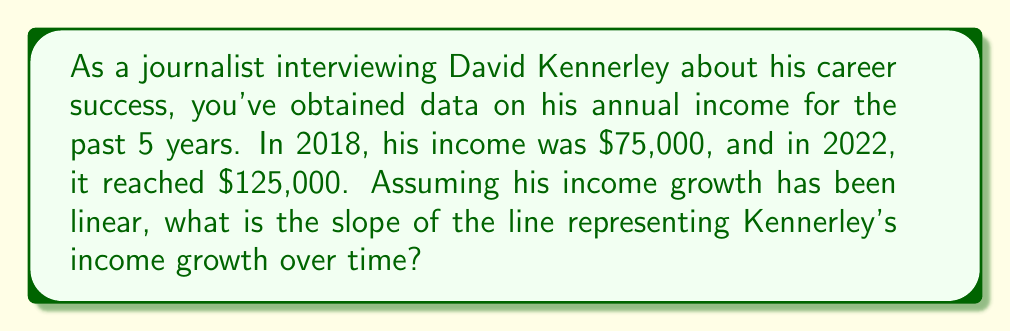Provide a solution to this math problem. To find the slope of the line representing Kennerley's income growth over time, we'll use the slope formula:

$$ m = \frac{y_2 - y_1}{x_2 - x_1} $$

Where:
- $m$ is the slope
- $(x_1, y_1)$ is the first point (2018, $75,000)
- $(x_2, y_2)$ is the second point (2022, $125,000)

Let's plug in the values:

$$ m = \frac{125,000 - 75,000}{2022 - 2018} $$

Simplify:

$$ m = \frac{50,000}{4} $$

Calculate:

$$ m = 12,500 $$

The slope represents the change in income per year. In this case, it's $12,500 per year.
Answer: $12,500 per year 